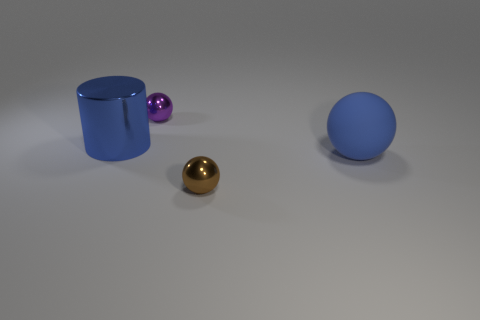Add 3 large shiny cylinders. How many objects exist? 7 Subtract all cylinders. How many objects are left? 3 Subtract 0 cyan cylinders. How many objects are left? 4 Subtract all big blue cubes. Subtract all blue objects. How many objects are left? 2 Add 2 tiny spheres. How many tiny spheres are left? 4 Add 4 small gray shiny cylinders. How many small gray shiny cylinders exist? 4 